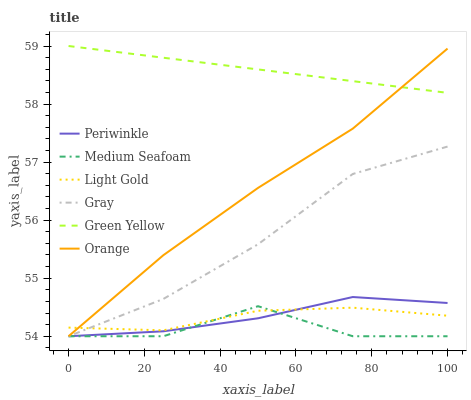Does Medium Seafoam have the minimum area under the curve?
Answer yes or no. Yes. Does Green Yellow have the maximum area under the curve?
Answer yes or no. Yes. Does Periwinkle have the minimum area under the curve?
Answer yes or no. No. Does Periwinkle have the maximum area under the curve?
Answer yes or no. No. Is Green Yellow the smoothest?
Answer yes or no. Yes. Is Medium Seafoam the roughest?
Answer yes or no. Yes. Is Periwinkle the smoothest?
Answer yes or no. No. Is Periwinkle the roughest?
Answer yes or no. No. Does Green Yellow have the lowest value?
Answer yes or no. No. Does Green Yellow have the highest value?
Answer yes or no. Yes. Does Periwinkle have the highest value?
Answer yes or no. No. Is Gray less than Green Yellow?
Answer yes or no. Yes. Is Green Yellow greater than Medium Seafoam?
Answer yes or no. Yes. Does Periwinkle intersect Light Gold?
Answer yes or no. Yes. Is Periwinkle less than Light Gold?
Answer yes or no. No. Is Periwinkle greater than Light Gold?
Answer yes or no. No. Does Gray intersect Green Yellow?
Answer yes or no. No. 